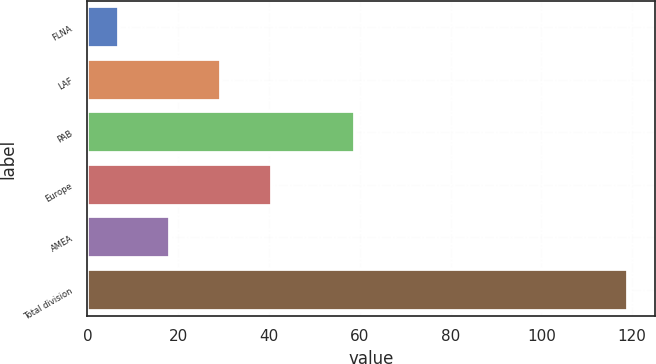Convert chart to OTSL. <chart><loc_0><loc_0><loc_500><loc_500><bar_chart><fcel>FLNA<fcel>LAF<fcel>PAB<fcel>Europe<fcel>AMEA<fcel>Total division<nl><fcel>7<fcel>29.4<fcel>59<fcel>40.6<fcel>18.2<fcel>119<nl></chart> 